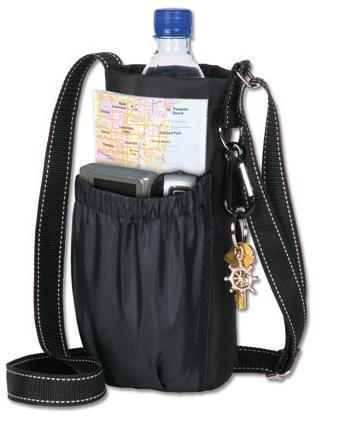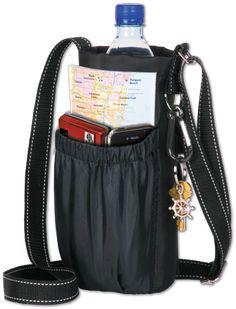The first image is the image on the left, the second image is the image on the right. Assess this claim about the two images: "A single bottle with a cap sits in a bag in each of the images.". Correct or not? Answer yes or no. Yes. The first image is the image on the left, the second image is the image on the right. Given the left and right images, does the statement "Right image includes a black bottle holder featuring a long strap and a pouch with an elasticized top, but the left image does not." hold true? Answer yes or no. No. 